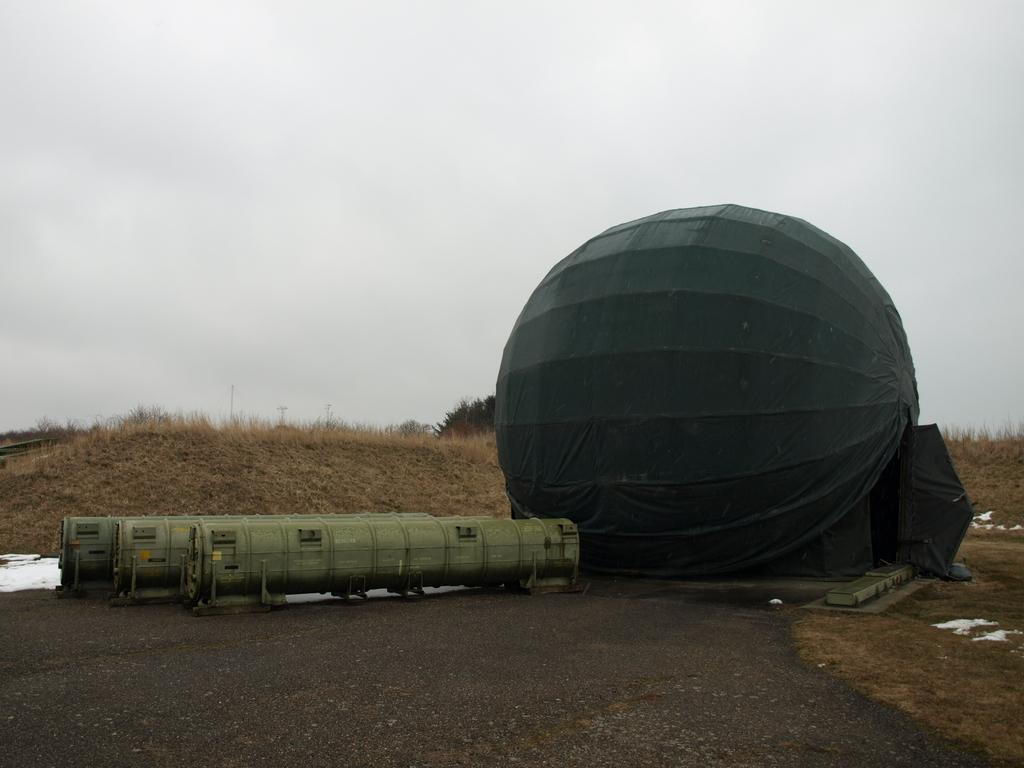What type of objects can be seen in the image? There are metal objects in the image. Can you describe the spherical object with a black cloth on it? Yes, it is a spherical object with a black cloth on it. What type of natural environment is visible in the image? Grass, trees, and the sky are visible in the image. What type of vase is being used to answer questions in the image? There is no vase present in the image, nor is there any indication of answering questions. What type of exchange is taking place between the trees in the image? There is no exchange taking place between the trees in the image; they are simply standing in the natural environment. 